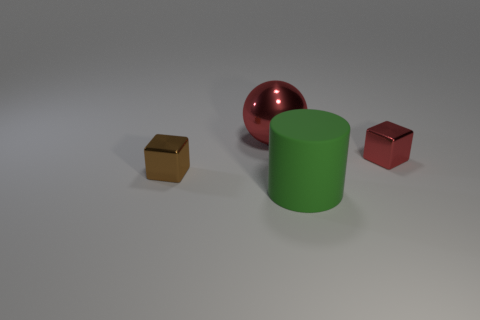Add 1 small metallic cylinders. How many objects exist? 5 Subtract all cylinders. How many objects are left? 3 Subtract 1 red balls. How many objects are left? 3 Subtract all gray cylinders. Subtract all purple blocks. How many cylinders are left? 1 Subtract all small metal things. Subtract all small blue things. How many objects are left? 2 Add 2 balls. How many balls are left? 3 Add 1 small brown things. How many small brown things exist? 2 